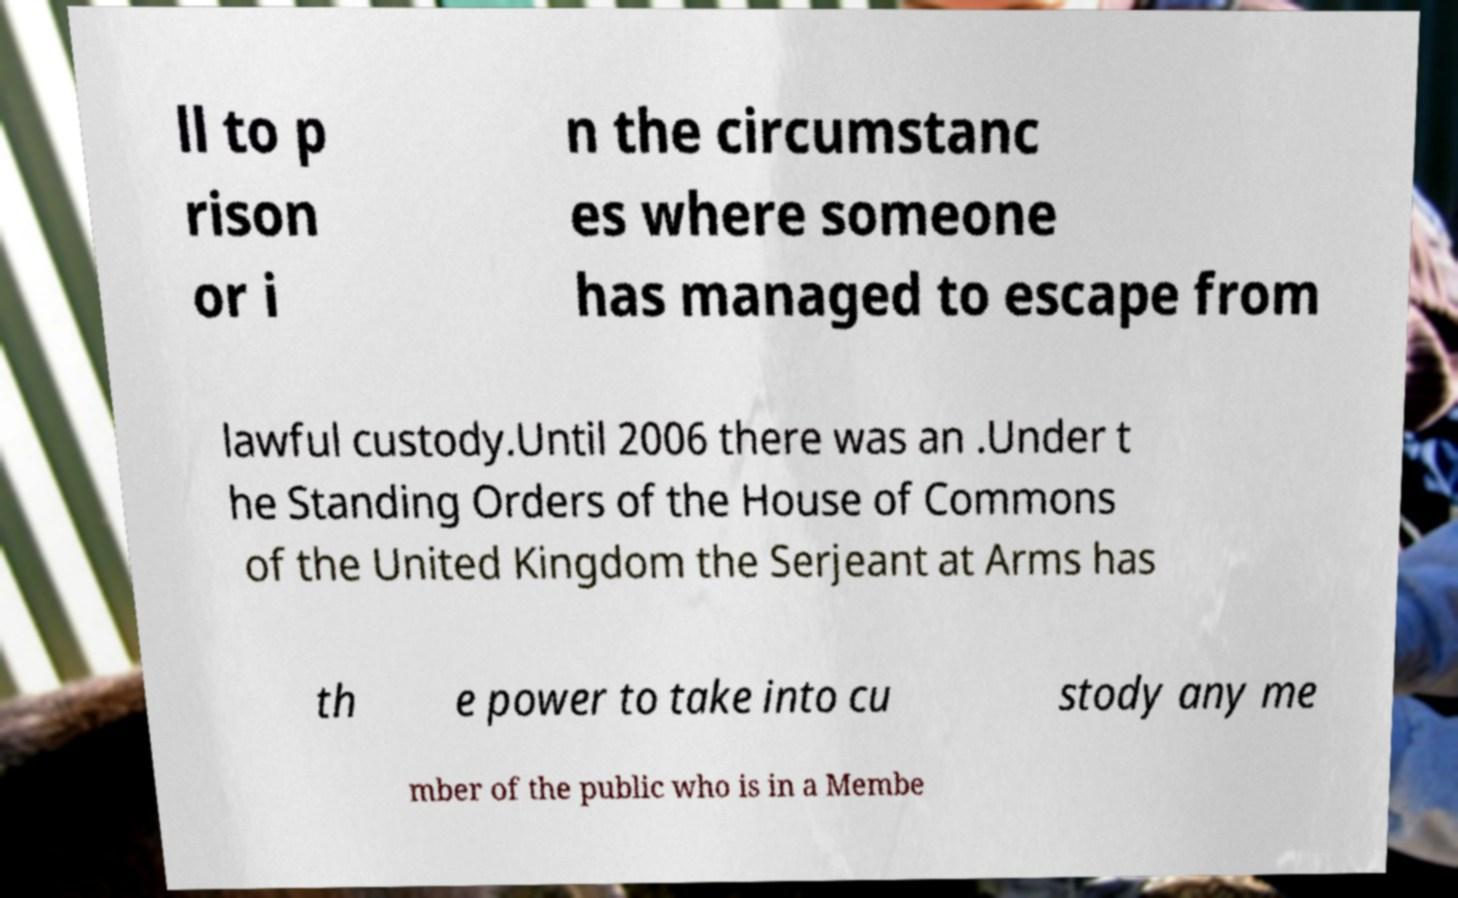Can you read and provide the text displayed in the image?This photo seems to have some interesting text. Can you extract and type it out for me? ll to p rison or i n the circumstanc es where someone has managed to escape from lawful custody.Until 2006 there was an .Under t he Standing Orders of the House of Commons of the United Kingdom the Serjeant at Arms has th e power to take into cu stody any me mber of the public who is in a Membe 